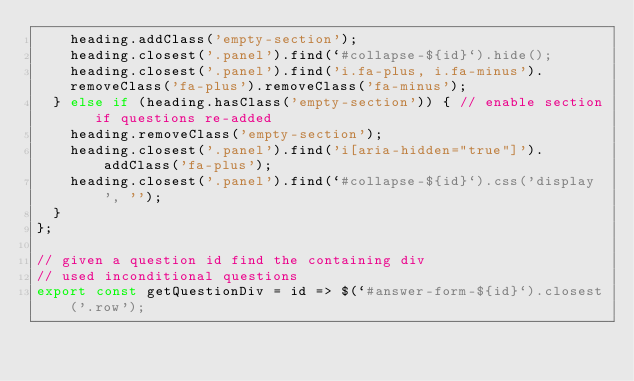Convert code to text. <code><loc_0><loc_0><loc_500><loc_500><_JavaScript_>    heading.addClass('empty-section');
    heading.closest('.panel').find(`#collapse-${id}`).hide();
    heading.closest('.panel').find('i.fa-plus, i.fa-minus').removeClass('fa-plus').removeClass('fa-minus');
  } else if (heading.hasClass('empty-section')) { // enable section if questions re-added
    heading.removeClass('empty-section');
    heading.closest('.panel').find('i[aria-hidden="true"]').addClass('fa-plus');
    heading.closest('.panel').find(`#collapse-${id}`).css('display', '');
  }
};

// given a question id find the containing div
// used inconditional questions
export const getQuestionDiv = id => $(`#answer-form-${id}`).closest('.row');
</code> 